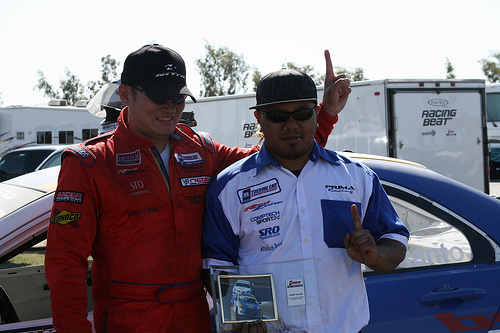<image>
Is the man next to the car? Yes. The man is positioned adjacent to the car, located nearby in the same general area. 